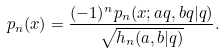Convert formula to latex. <formula><loc_0><loc_0><loc_500><loc_500>p _ { n } ( x ) & = \frac { ( - 1 ) ^ { n } p _ { n } ( x ; a q , b q | q ) } { \sqrt { h _ { n } ( a , b | q ) } } .</formula> 